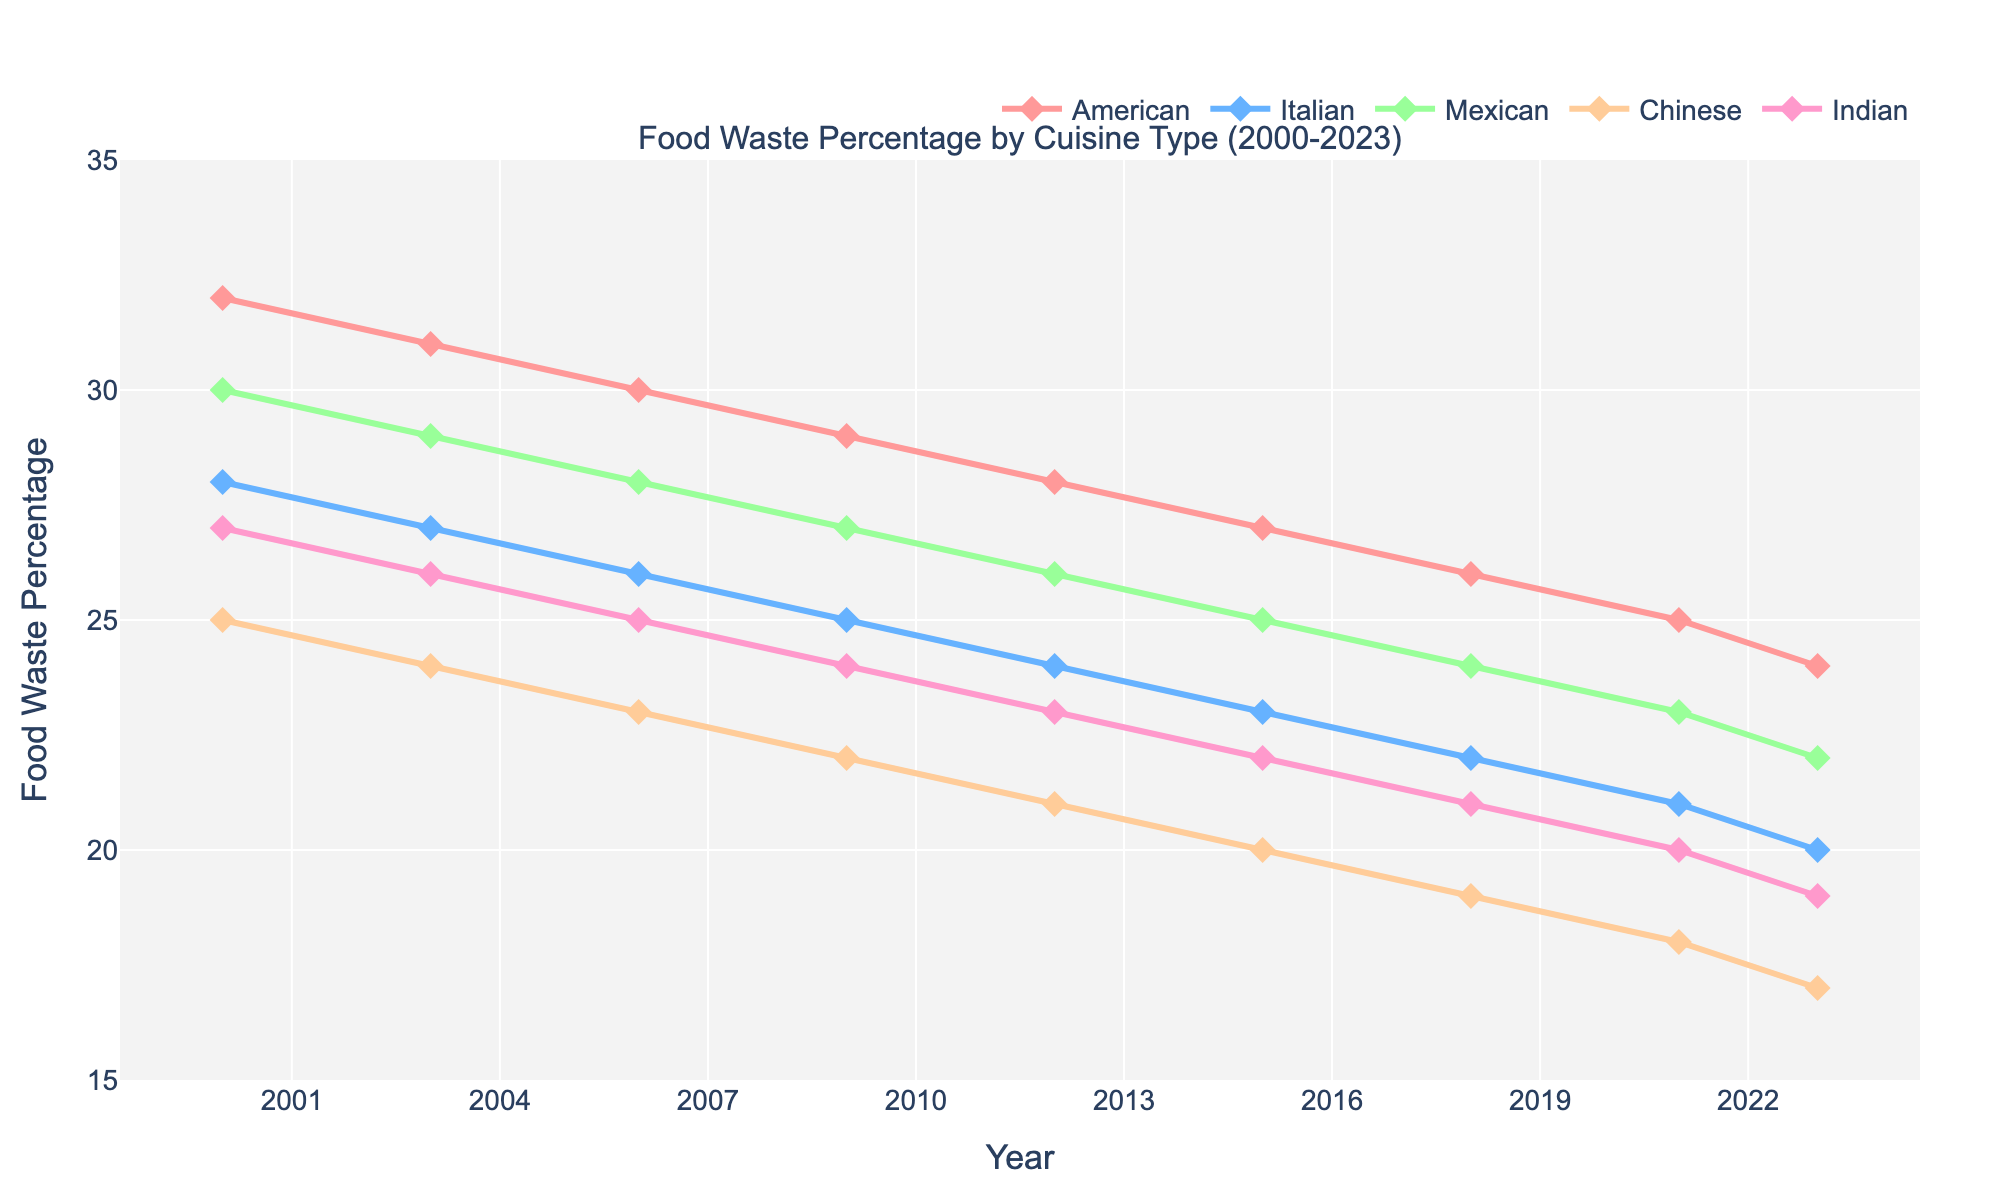What was the percentage decrease in food waste for Indian cuisine from 2000 to 2023? The percentage of food waste for Indian cuisine in 2000 was 27%. In 2023, it decreased to 19%. The decrease is 27% - 19% = 8%.
Answer: 8% Which cuisine had the highest food waste percentage in 2000? To find the highest food waste percentage in 2000, check the values: American (32%), Italian (28%), Mexican (30%), Chinese (25%), Indian (27%). The highest is American with 32%.
Answer: American Across the years shown, did Mexican cuisine ever have a lower food waste percentage than Chinese cuisine? By scanning the available years, we notice from the data that Mexican cuisine started at 30% and decreased to 22%, while Chinese cuisine started at 25% and decreased to 17%. Hence, Mexican cuisine always had a higher food waste percentage than Chinese cuisine.
Answer: No How does the food waste percentage trend for Italian cuisine compare to Mexican cuisine from 2000 to 2023? Comparing the waste percentages, Italian cuisine decreases steadily from 28% to 20%, while Mexican cuisine decreases from 30% to 22%. The rates of decrease are similar, but Italian cuisine remains consistently lower than Mexican cuisine throughout the years.
Answer: Italian is consistently lower Which cuisine saw the smallest decrease in food waste percentage from 2000 to 2023? Calculate the decrease for each cuisine: American (32% to 24%) = 8%, Italian (28% to 20%) = 8%, Mexican (30% to 22%) = 8%, Chinese (25% to 17%) = 8%, Indian (27% to 19%) = 8%. All have identical decreases of 8%.
Answer: All are equal In which year did all the cuisines first drop below 30% food waste? Review each year's food waste percentages: In 2006, American is 30%, Italian 26%, Mexican 28%, Chinese 23%, and Indian 25%. This is the first year all dropped below 30%.
Answer: 2006 What is the average percentage of food waste for American cuisine for the years provided? Sum the percentages for each year for American cuisine: 32 + 31 + 30 + 29 + 28 + 27 + 26 + 25 + 24 = 252. Divide by the number of years (9): 252 / 9 ≈ 28%.
Answer: 28% How much did the food waste percentage for Chinese cuisine decrease between 2006 and 2015? Subtract the 2015 value from the 2006 value for Chinese cuisine: 23% - 20% = 3%.
Answer: 3% Which two cuisines showed the same percentage of decrease in food waste from 2018 to 2023? Calculate the decrease for each cuisine between 2018 and 2023: American (26% to 24%) = 2%, Italian (22% to 20%) = 2%, Mexican (24% to 22%) = 2%, Chinese (19% to 17%) = 2%, Indian (21% to 19%) = 2%. All cuisines had the same decrease of 2%.
Answer: All are equal Can you identify a year where two or more cuisines had the same food waste percentage? In 2021, both Mexican and Italian cuisines had the same food waste percentage of 21%.
Answer: 2021 